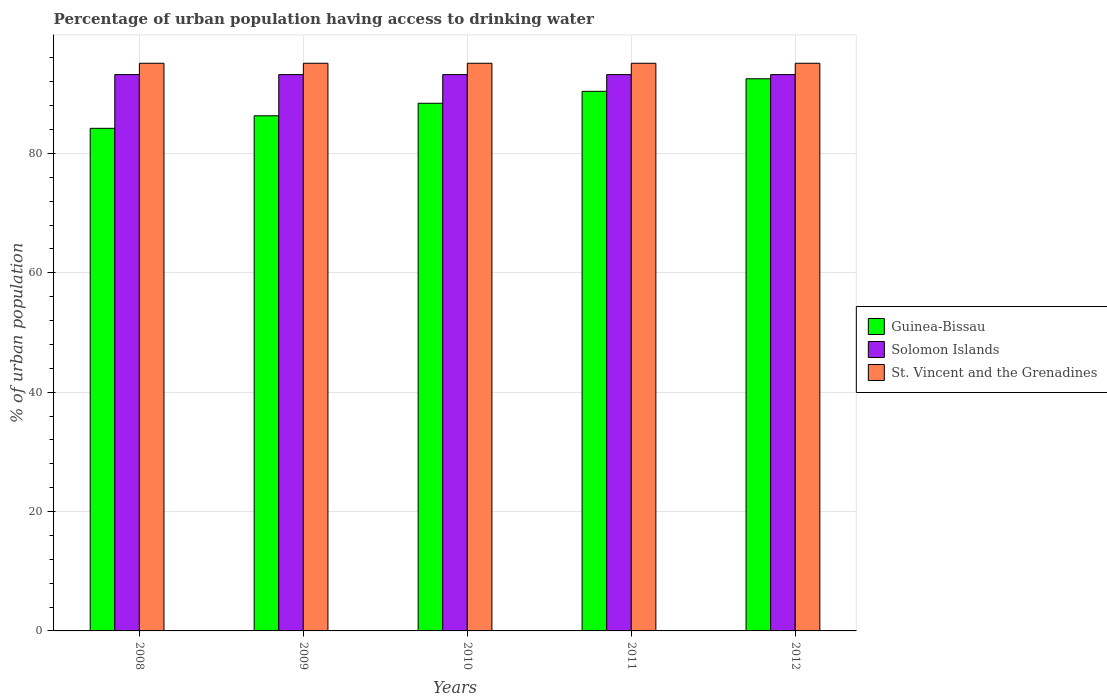How many different coloured bars are there?
Your response must be concise. 3. How many groups of bars are there?
Your response must be concise. 5. Are the number of bars per tick equal to the number of legend labels?
Your answer should be very brief. Yes. Are the number of bars on each tick of the X-axis equal?
Offer a terse response. Yes. How many bars are there on the 2nd tick from the left?
Your answer should be very brief. 3. How many bars are there on the 3rd tick from the right?
Your response must be concise. 3. What is the label of the 5th group of bars from the left?
Provide a succinct answer. 2012. In how many cases, is the number of bars for a given year not equal to the number of legend labels?
Ensure brevity in your answer.  0. What is the percentage of urban population having access to drinking water in Guinea-Bissau in 2009?
Ensure brevity in your answer.  86.3. Across all years, what is the maximum percentage of urban population having access to drinking water in St. Vincent and the Grenadines?
Your answer should be very brief. 95.1. Across all years, what is the minimum percentage of urban population having access to drinking water in Solomon Islands?
Provide a short and direct response. 93.2. In which year was the percentage of urban population having access to drinking water in Guinea-Bissau minimum?
Ensure brevity in your answer.  2008. What is the total percentage of urban population having access to drinking water in Guinea-Bissau in the graph?
Provide a succinct answer. 441.8. What is the difference between the percentage of urban population having access to drinking water in Solomon Islands in 2008 and that in 2009?
Ensure brevity in your answer.  0. What is the difference between the percentage of urban population having access to drinking water in Guinea-Bissau in 2010 and the percentage of urban population having access to drinking water in Solomon Islands in 2009?
Offer a terse response. -4.8. What is the average percentage of urban population having access to drinking water in St. Vincent and the Grenadines per year?
Your response must be concise. 95.1. In the year 2008, what is the difference between the percentage of urban population having access to drinking water in Guinea-Bissau and percentage of urban population having access to drinking water in St. Vincent and the Grenadines?
Offer a very short reply. -10.9. In how many years, is the percentage of urban population having access to drinking water in St. Vincent and the Grenadines greater than 20 %?
Keep it short and to the point. 5. What is the ratio of the percentage of urban population having access to drinking water in Solomon Islands in 2008 to that in 2011?
Offer a very short reply. 1. Is the percentage of urban population having access to drinking water in Guinea-Bissau in 2008 less than that in 2010?
Offer a terse response. Yes. What is the difference between the highest and the lowest percentage of urban population having access to drinking water in St. Vincent and the Grenadines?
Your response must be concise. 0. In how many years, is the percentage of urban population having access to drinking water in Solomon Islands greater than the average percentage of urban population having access to drinking water in Solomon Islands taken over all years?
Give a very brief answer. 0. Is the sum of the percentage of urban population having access to drinking water in St. Vincent and the Grenadines in 2009 and 2012 greater than the maximum percentage of urban population having access to drinking water in Solomon Islands across all years?
Provide a succinct answer. Yes. What does the 2nd bar from the left in 2011 represents?
Offer a terse response. Solomon Islands. What does the 1st bar from the right in 2010 represents?
Offer a very short reply. St. Vincent and the Grenadines. Are all the bars in the graph horizontal?
Your response must be concise. No. How many years are there in the graph?
Offer a terse response. 5. What is the difference between two consecutive major ticks on the Y-axis?
Provide a succinct answer. 20. Are the values on the major ticks of Y-axis written in scientific E-notation?
Your answer should be compact. No. Does the graph contain any zero values?
Provide a short and direct response. No. Where does the legend appear in the graph?
Ensure brevity in your answer.  Center right. How many legend labels are there?
Give a very brief answer. 3. How are the legend labels stacked?
Offer a terse response. Vertical. What is the title of the graph?
Your answer should be compact. Percentage of urban population having access to drinking water. Does "Upper middle income" appear as one of the legend labels in the graph?
Keep it short and to the point. No. What is the label or title of the Y-axis?
Your answer should be very brief. % of urban population. What is the % of urban population of Guinea-Bissau in 2008?
Your response must be concise. 84.2. What is the % of urban population in Solomon Islands in 2008?
Your answer should be compact. 93.2. What is the % of urban population in St. Vincent and the Grenadines in 2008?
Offer a very short reply. 95.1. What is the % of urban population in Guinea-Bissau in 2009?
Offer a terse response. 86.3. What is the % of urban population in Solomon Islands in 2009?
Provide a succinct answer. 93.2. What is the % of urban population of St. Vincent and the Grenadines in 2009?
Your answer should be compact. 95.1. What is the % of urban population in Guinea-Bissau in 2010?
Your answer should be very brief. 88.4. What is the % of urban population in Solomon Islands in 2010?
Provide a succinct answer. 93.2. What is the % of urban population of St. Vincent and the Grenadines in 2010?
Make the answer very short. 95.1. What is the % of urban population in Guinea-Bissau in 2011?
Offer a terse response. 90.4. What is the % of urban population in Solomon Islands in 2011?
Give a very brief answer. 93.2. What is the % of urban population of St. Vincent and the Grenadines in 2011?
Your answer should be compact. 95.1. What is the % of urban population in Guinea-Bissau in 2012?
Ensure brevity in your answer.  92.5. What is the % of urban population in Solomon Islands in 2012?
Keep it short and to the point. 93.2. What is the % of urban population in St. Vincent and the Grenadines in 2012?
Your answer should be compact. 95.1. Across all years, what is the maximum % of urban population in Guinea-Bissau?
Ensure brevity in your answer.  92.5. Across all years, what is the maximum % of urban population of Solomon Islands?
Your answer should be very brief. 93.2. Across all years, what is the maximum % of urban population of St. Vincent and the Grenadines?
Ensure brevity in your answer.  95.1. Across all years, what is the minimum % of urban population of Guinea-Bissau?
Give a very brief answer. 84.2. Across all years, what is the minimum % of urban population in Solomon Islands?
Offer a very short reply. 93.2. Across all years, what is the minimum % of urban population in St. Vincent and the Grenadines?
Provide a succinct answer. 95.1. What is the total % of urban population of Guinea-Bissau in the graph?
Your response must be concise. 441.8. What is the total % of urban population in Solomon Islands in the graph?
Offer a terse response. 466. What is the total % of urban population of St. Vincent and the Grenadines in the graph?
Your response must be concise. 475.5. What is the difference between the % of urban population in Solomon Islands in 2008 and that in 2009?
Ensure brevity in your answer.  0. What is the difference between the % of urban population in Guinea-Bissau in 2008 and that in 2010?
Your response must be concise. -4.2. What is the difference between the % of urban population of Solomon Islands in 2008 and that in 2010?
Give a very brief answer. 0. What is the difference between the % of urban population of St. Vincent and the Grenadines in 2008 and that in 2010?
Give a very brief answer. 0. What is the difference between the % of urban population in Guinea-Bissau in 2008 and that in 2011?
Offer a very short reply. -6.2. What is the difference between the % of urban population of Solomon Islands in 2008 and that in 2011?
Offer a very short reply. 0. What is the difference between the % of urban population of St. Vincent and the Grenadines in 2008 and that in 2011?
Provide a succinct answer. 0. What is the difference between the % of urban population in Guinea-Bissau in 2008 and that in 2012?
Provide a short and direct response. -8.3. What is the difference between the % of urban population of Solomon Islands in 2008 and that in 2012?
Offer a terse response. 0. What is the difference between the % of urban population in Solomon Islands in 2009 and that in 2010?
Offer a terse response. 0. What is the difference between the % of urban population in Guinea-Bissau in 2009 and that in 2011?
Your response must be concise. -4.1. What is the difference between the % of urban population of St. Vincent and the Grenadines in 2009 and that in 2011?
Your answer should be very brief. 0. What is the difference between the % of urban population in Solomon Islands in 2009 and that in 2012?
Keep it short and to the point. 0. What is the difference between the % of urban population in Solomon Islands in 2010 and that in 2011?
Give a very brief answer. 0. What is the difference between the % of urban population in Guinea-Bissau in 2010 and that in 2012?
Make the answer very short. -4.1. What is the difference between the % of urban population of Solomon Islands in 2010 and that in 2012?
Your response must be concise. 0. What is the difference between the % of urban population in St. Vincent and the Grenadines in 2010 and that in 2012?
Ensure brevity in your answer.  0. What is the difference between the % of urban population in St. Vincent and the Grenadines in 2011 and that in 2012?
Your response must be concise. 0. What is the difference between the % of urban population in Guinea-Bissau in 2008 and the % of urban population in St. Vincent and the Grenadines in 2009?
Provide a succinct answer. -10.9. What is the difference between the % of urban population in Solomon Islands in 2008 and the % of urban population in St. Vincent and the Grenadines in 2009?
Give a very brief answer. -1.9. What is the difference between the % of urban population of Guinea-Bissau in 2008 and the % of urban population of Solomon Islands in 2010?
Your answer should be compact. -9. What is the difference between the % of urban population of Guinea-Bissau in 2008 and the % of urban population of Solomon Islands in 2011?
Ensure brevity in your answer.  -9. What is the difference between the % of urban population of Guinea-Bissau in 2008 and the % of urban population of St. Vincent and the Grenadines in 2011?
Your answer should be very brief. -10.9. What is the difference between the % of urban population of Solomon Islands in 2008 and the % of urban population of St. Vincent and the Grenadines in 2011?
Provide a short and direct response. -1.9. What is the difference between the % of urban population in Solomon Islands in 2008 and the % of urban population in St. Vincent and the Grenadines in 2012?
Keep it short and to the point. -1.9. What is the difference between the % of urban population in Guinea-Bissau in 2009 and the % of urban population in St. Vincent and the Grenadines in 2010?
Offer a terse response. -8.8. What is the difference between the % of urban population of Solomon Islands in 2009 and the % of urban population of St. Vincent and the Grenadines in 2010?
Your answer should be compact. -1.9. What is the difference between the % of urban population in Guinea-Bissau in 2009 and the % of urban population in St. Vincent and the Grenadines in 2011?
Give a very brief answer. -8.8. What is the difference between the % of urban population of Guinea-Bissau in 2009 and the % of urban population of Solomon Islands in 2012?
Your answer should be very brief. -6.9. What is the difference between the % of urban population of Solomon Islands in 2009 and the % of urban population of St. Vincent and the Grenadines in 2012?
Keep it short and to the point. -1.9. What is the difference between the % of urban population of Guinea-Bissau in 2010 and the % of urban population of Solomon Islands in 2011?
Provide a short and direct response. -4.8. What is the difference between the % of urban population in Solomon Islands in 2010 and the % of urban population in St. Vincent and the Grenadines in 2011?
Give a very brief answer. -1.9. What is the difference between the % of urban population of Guinea-Bissau in 2010 and the % of urban population of St. Vincent and the Grenadines in 2012?
Your answer should be compact. -6.7. What is the difference between the % of urban population of Solomon Islands in 2010 and the % of urban population of St. Vincent and the Grenadines in 2012?
Provide a short and direct response. -1.9. What is the difference between the % of urban population of Guinea-Bissau in 2011 and the % of urban population of Solomon Islands in 2012?
Make the answer very short. -2.8. What is the difference between the % of urban population in Solomon Islands in 2011 and the % of urban population in St. Vincent and the Grenadines in 2012?
Ensure brevity in your answer.  -1.9. What is the average % of urban population in Guinea-Bissau per year?
Give a very brief answer. 88.36. What is the average % of urban population in Solomon Islands per year?
Give a very brief answer. 93.2. What is the average % of urban population of St. Vincent and the Grenadines per year?
Offer a terse response. 95.1. In the year 2008, what is the difference between the % of urban population in Guinea-Bissau and % of urban population in Solomon Islands?
Offer a very short reply. -9. In the year 2008, what is the difference between the % of urban population in Solomon Islands and % of urban population in St. Vincent and the Grenadines?
Make the answer very short. -1.9. In the year 2009, what is the difference between the % of urban population of Guinea-Bissau and % of urban population of Solomon Islands?
Your answer should be compact. -6.9. In the year 2009, what is the difference between the % of urban population of Guinea-Bissau and % of urban population of St. Vincent and the Grenadines?
Your answer should be very brief. -8.8. In the year 2009, what is the difference between the % of urban population of Solomon Islands and % of urban population of St. Vincent and the Grenadines?
Offer a very short reply. -1.9. In the year 2010, what is the difference between the % of urban population of Guinea-Bissau and % of urban population of St. Vincent and the Grenadines?
Ensure brevity in your answer.  -6.7. In the year 2010, what is the difference between the % of urban population in Solomon Islands and % of urban population in St. Vincent and the Grenadines?
Offer a very short reply. -1.9. In the year 2011, what is the difference between the % of urban population in Guinea-Bissau and % of urban population in Solomon Islands?
Ensure brevity in your answer.  -2.8. In the year 2011, what is the difference between the % of urban population of Guinea-Bissau and % of urban population of St. Vincent and the Grenadines?
Your answer should be compact. -4.7. In the year 2012, what is the difference between the % of urban population in Guinea-Bissau and % of urban population in St. Vincent and the Grenadines?
Your answer should be very brief. -2.6. In the year 2012, what is the difference between the % of urban population in Solomon Islands and % of urban population in St. Vincent and the Grenadines?
Give a very brief answer. -1.9. What is the ratio of the % of urban population in Guinea-Bissau in 2008 to that in 2009?
Provide a short and direct response. 0.98. What is the ratio of the % of urban population in Solomon Islands in 2008 to that in 2009?
Provide a succinct answer. 1. What is the ratio of the % of urban population in St. Vincent and the Grenadines in 2008 to that in 2009?
Keep it short and to the point. 1. What is the ratio of the % of urban population in Guinea-Bissau in 2008 to that in 2010?
Offer a terse response. 0.95. What is the ratio of the % of urban population in Guinea-Bissau in 2008 to that in 2011?
Offer a terse response. 0.93. What is the ratio of the % of urban population in Solomon Islands in 2008 to that in 2011?
Provide a short and direct response. 1. What is the ratio of the % of urban population in Guinea-Bissau in 2008 to that in 2012?
Give a very brief answer. 0.91. What is the ratio of the % of urban population in St. Vincent and the Grenadines in 2008 to that in 2012?
Give a very brief answer. 1. What is the ratio of the % of urban population of Guinea-Bissau in 2009 to that in 2010?
Your answer should be compact. 0.98. What is the ratio of the % of urban population in Solomon Islands in 2009 to that in 2010?
Offer a terse response. 1. What is the ratio of the % of urban population in St. Vincent and the Grenadines in 2009 to that in 2010?
Your answer should be compact. 1. What is the ratio of the % of urban population in Guinea-Bissau in 2009 to that in 2011?
Your answer should be very brief. 0.95. What is the ratio of the % of urban population in Solomon Islands in 2009 to that in 2011?
Offer a very short reply. 1. What is the ratio of the % of urban population of St. Vincent and the Grenadines in 2009 to that in 2011?
Offer a very short reply. 1. What is the ratio of the % of urban population in Guinea-Bissau in 2009 to that in 2012?
Give a very brief answer. 0.93. What is the ratio of the % of urban population of St. Vincent and the Grenadines in 2009 to that in 2012?
Give a very brief answer. 1. What is the ratio of the % of urban population of Guinea-Bissau in 2010 to that in 2011?
Keep it short and to the point. 0.98. What is the ratio of the % of urban population in Solomon Islands in 2010 to that in 2011?
Offer a very short reply. 1. What is the ratio of the % of urban population of St. Vincent and the Grenadines in 2010 to that in 2011?
Your answer should be very brief. 1. What is the ratio of the % of urban population of Guinea-Bissau in 2010 to that in 2012?
Provide a succinct answer. 0.96. What is the ratio of the % of urban population of Solomon Islands in 2010 to that in 2012?
Your answer should be compact. 1. What is the ratio of the % of urban population in Guinea-Bissau in 2011 to that in 2012?
Provide a succinct answer. 0.98. What is the ratio of the % of urban population of Solomon Islands in 2011 to that in 2012?
Your answer should be compact. 1. What is the ratio of the % of urban population of St. Vincent and the Grenadines in 2011 to that in 2012?
Your answer should be very brief. 1. What is the difference between the highest and the second highest % of urban population of Guinea-Bissau?
Make the answer very short. 2.1. What is the difference between the highest and the lowest % of urban population of Guinea-Bissau?
Your answer should be compact. 8.3. What is the difference between the highest and the lowest % of urban population in Solomon Islands?
Offer a terse response. 0. What is the difference between the highest and the lowest % of urban population of St. Vincent and the Grenadines?
Offer a terse response. 0. 